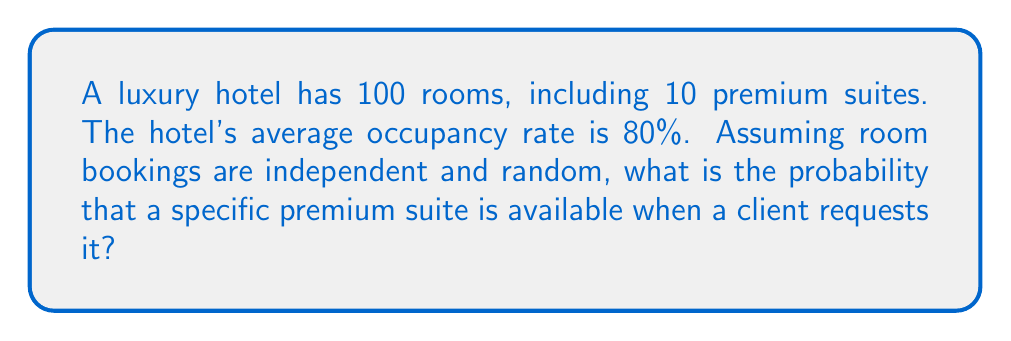Can you solve this math problem? Let's approach this step-by-step:

1) First, we need to calculate the probability that any given room is occupied:
   $P(\text{room is occupied}) = 0.80$ (given occupancy rate)

2) Therefore, the probability that any given room is available is:
   $P(\text{room is available}) = 1 - P(\text{room is occupied}) = 1 - 0.80 = 0.20$

3) Now, we're interested in a specific premium suite. The availability of this suite is independent of other rooms, so its probability of being available is the same as any other room:
   $P(\text{specific suite is available}) = 0.20$

4) We can verify this using the binomial probability formula:
   $$P(X = k) = \binom{n}{k} p^k (1-p)^{n-k}$$
   
   Where:
   $n$ = total number of rooms = 100
   $k$ = number of available rooms = 20 (20% of 100)
   $p$ = probability of a room being available = 0.20

   $$P(X = 20) = \binom{100}{20} (0.20)^{20} (0.80)^{80} \approx 0.0998$$

   This is the probability of exactly 20 rooms being available, which is the most likely scenario given the 80% occupancy rate.

5) The probability of our specific suite being among these available rooms remains 0.20, regardless of which exact rooms are available.
Answer: 0.20 